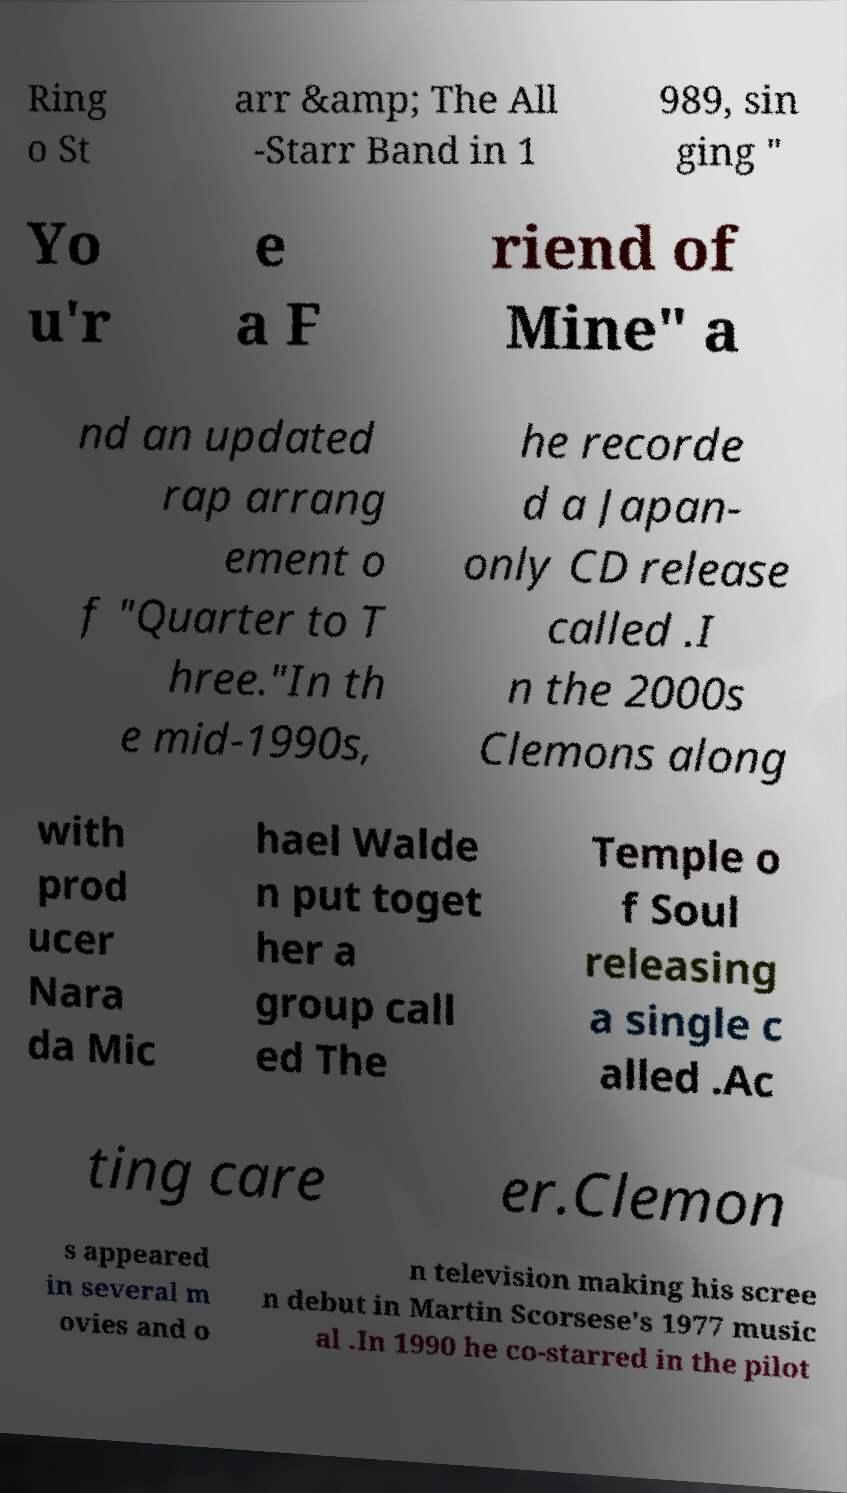Please identify and transcribe the text found in this image. Ring o St arr &amp; The All -Starr Band in 1 989, sin ging " Yo u'r e a F riend of Mine" a nd an updated rap arrang ement o f "Quarter to T hree."In th e mid-1990s, he recorde d a Japan- only CD release called .I n the 2000s Clemons along with prod ucer Nara da Mic hael Walde n put toget her a group call ed The Temple o f Soul releasing a single c alled .Ac ting care er.Clemon s appeared in several m ovies and o n television making his scree n debut in Martin Scorsese's 1977 music al .In 1990 he co-starred in the pilot 